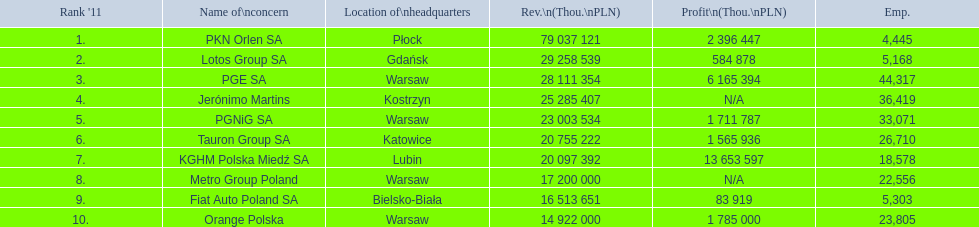What are the names of all the concerns? PKN Orlen SA, Lotos Group SA, PGE SA, Jerónimo Martins, PGNiG SA, Tauron Group SA, KGHM Polska Miedź SA, Metro Group Poland, Fiat Auto Poland SA, Orange Polska. How many employees does pgnig sa have? 33,071. 